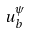<formula> <loc_0><loc_0><loc_500><loc_500>u _ { b } ^ { \psi }</formula> 